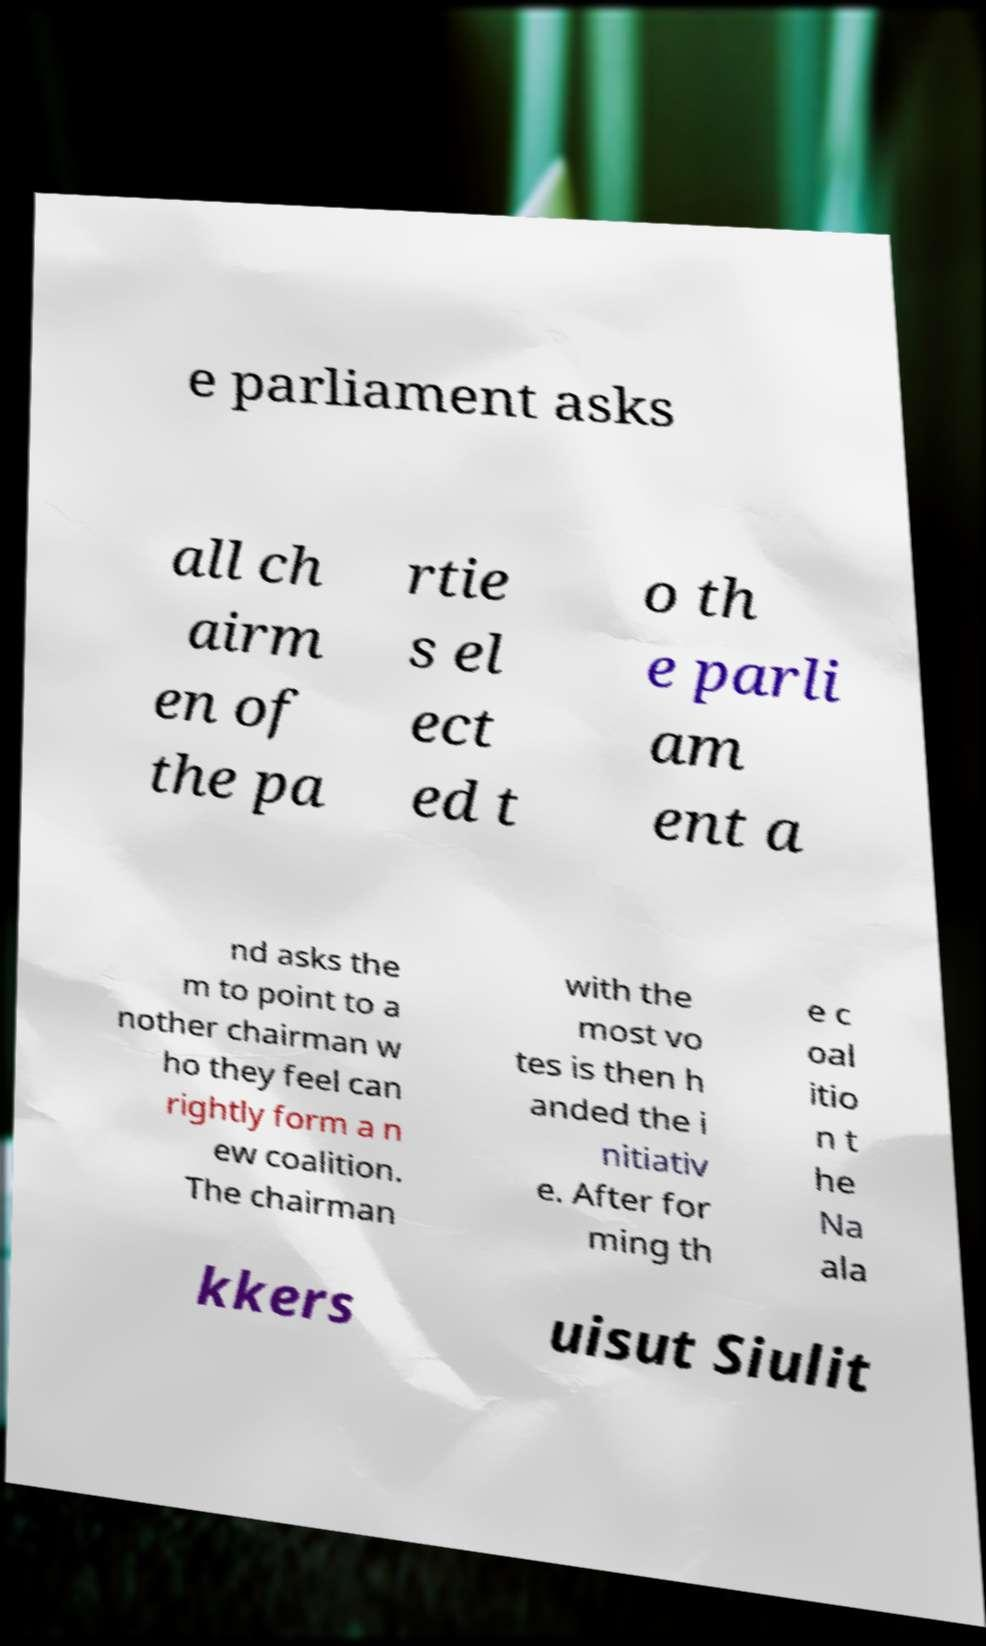I need the written content from this picture converted into text. Can you do that? e parliament asks all ch airm en of the pa rtie s el ect ed t o th e parli am ent a nd asks the m to point to a nother chairman w ho they feel can rightly form a n ew coalition. The chairman with the most vo tes is then h anded the i nitiativ e. After for ming th e c oal itio n t he Na ala kkers uisut Siulit 